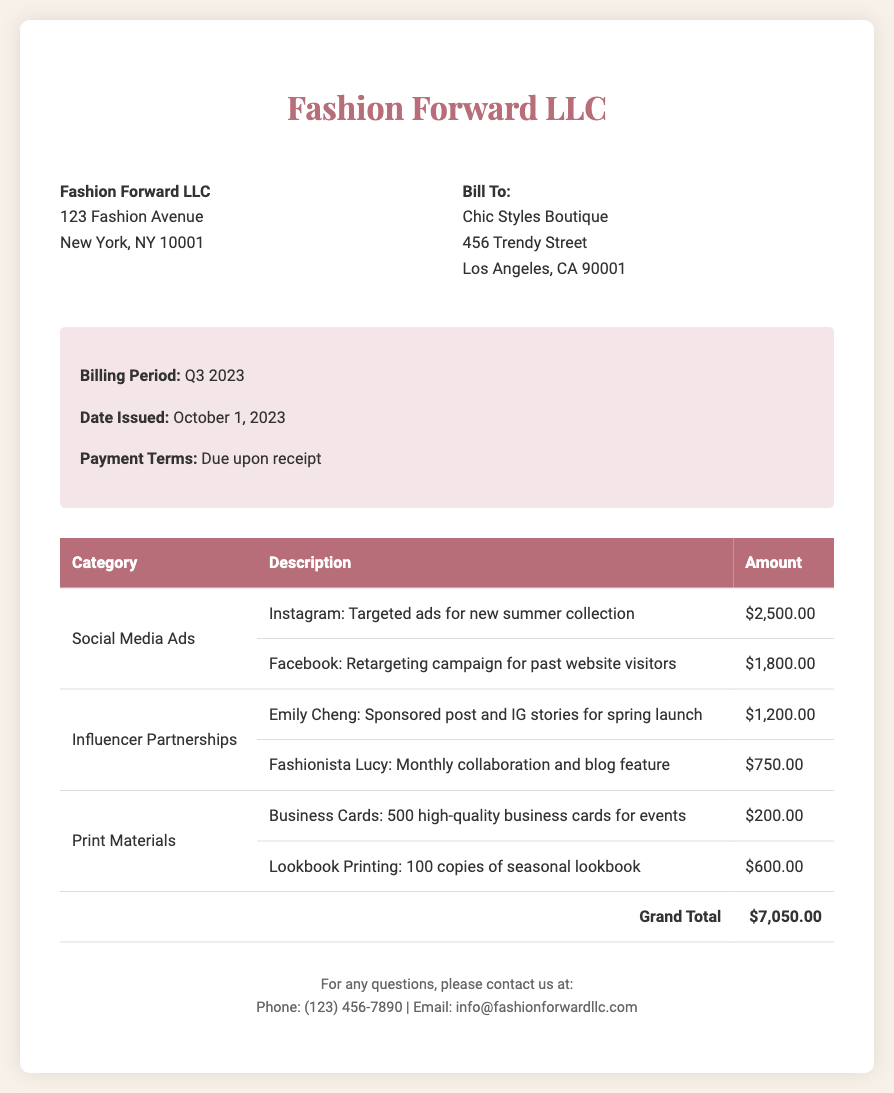what is the total amount billed? The total amount billed is indicated as the Grand Total in the document, which sums all categories.
Answer: $7,050.00 what is the payment term? The payment term specifies the conditions under which payment is expected, detailed in the document.
Answer: Due upon receipt who is billed in this document? The document specifies the client being billed for the services rendered.
Answer: Chic Styles Boutique what is the amount for Instagram ads? The document itemizes the costs for Instagram ads as listed under Social Media Ads.
Answer: $2,500.00 how many business cards were printed? The document specifies the quantity of business cards printed, included under Print Materials.
Answer: 500 what was the date issued for this bill? The date issued is provided in the bill details section and indicates when the bill was sent.
Answer: October 1, 2023 who collaborated with the company for social media influencer posts? The document lists the influencers and their respective collaborations mentioned under Influencer Partnerships.
Answer: Emily Cheng how many copies of the lookbook were printed? The quantity printed for the lookbook is specified in the description under Print Materials.
Answer: 100 copies 